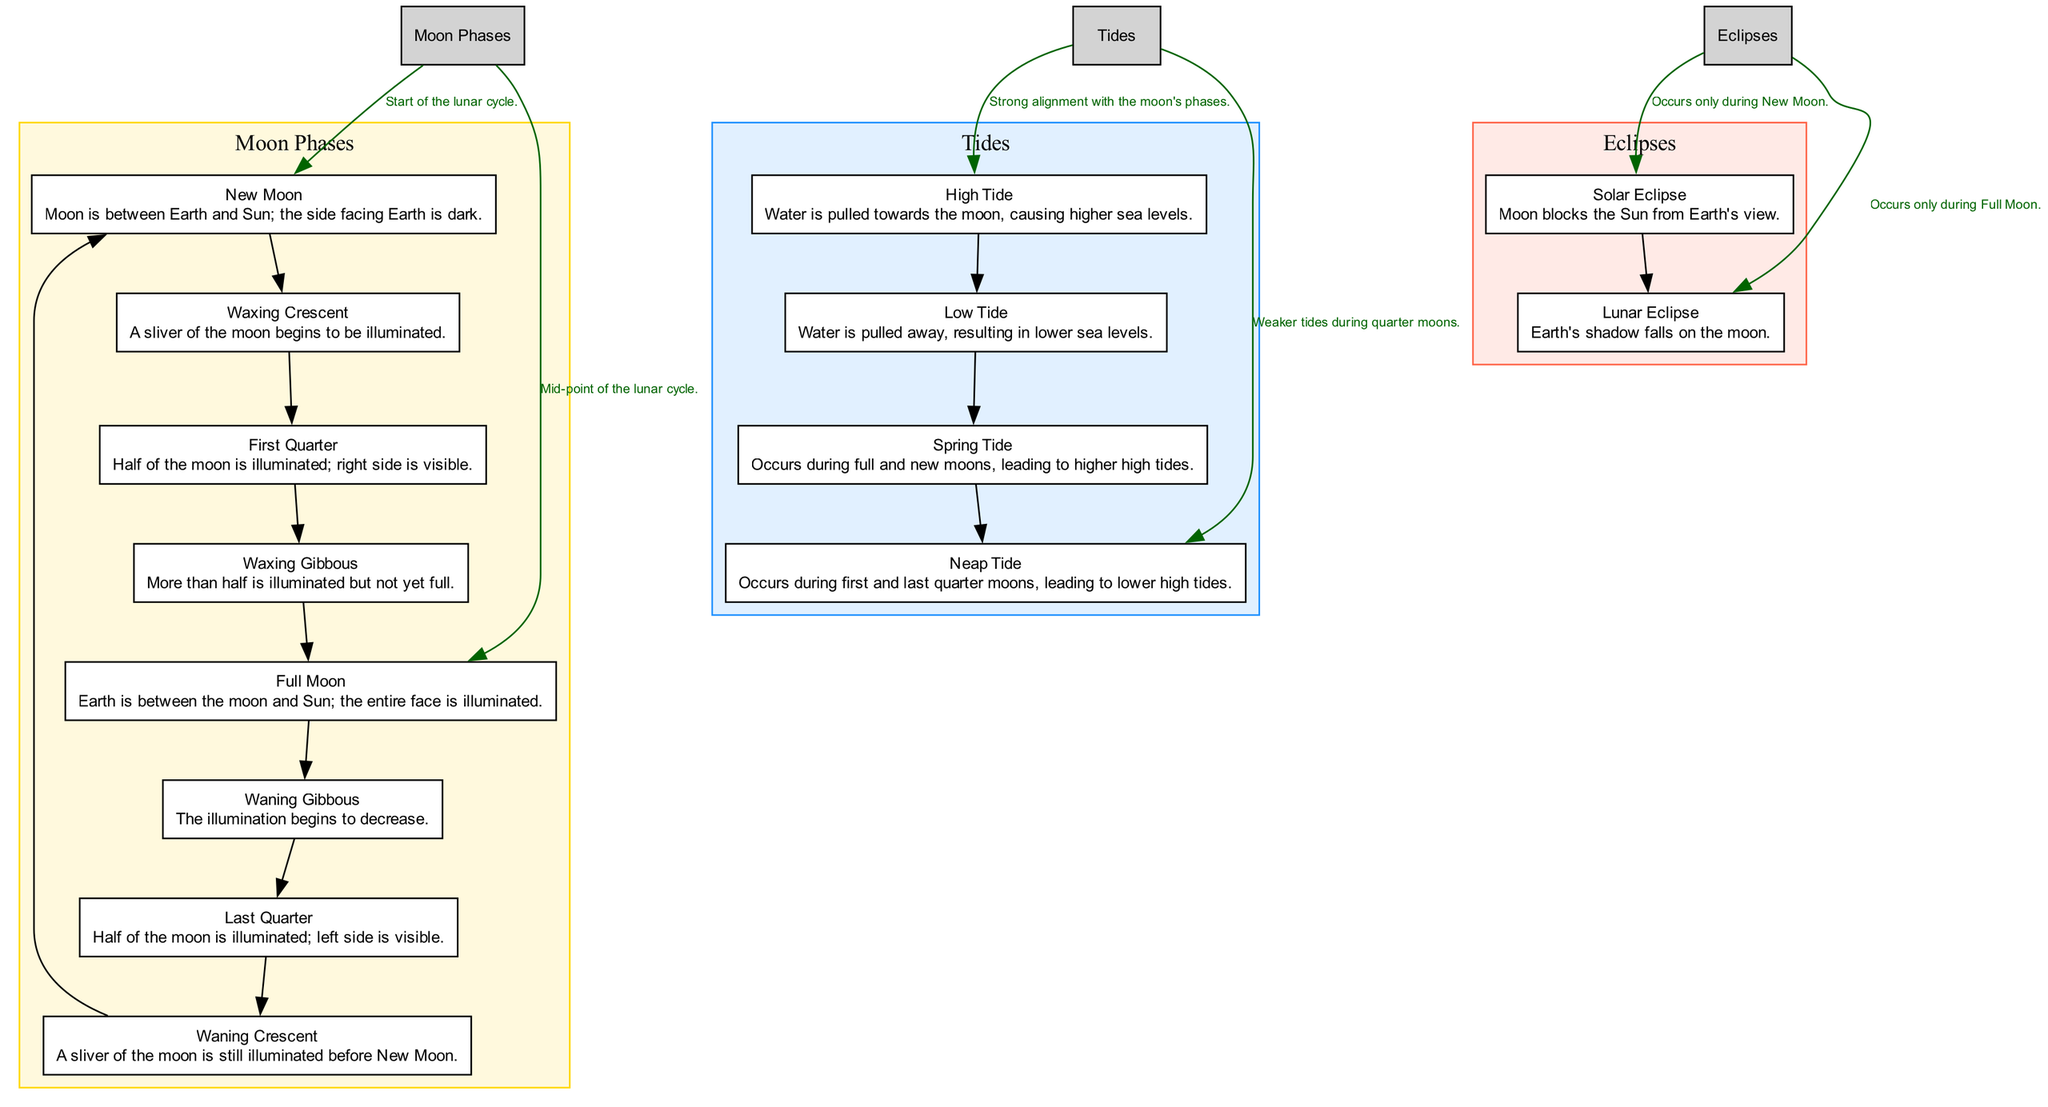What is the first phase of the moon? The diagram clearly indicates that the first phase in the Moon Phases section is labeled "New Moon."
Answer: New Moon How many phases of the moon are shown in the diagram? Counting the nodes under the Moon Phases section, there are eight distinct phases listed, from New Moon to Waning Crescent.
Answer: Eight What phase of the moon is directly before the Full Moon? The diagram reflects that the phase prior to the Full Moon is the Waxing Gibbous in the Moon Phases section.
Answer: Waxing Gibbous During which moon phase does a Solar Eclipse occur? The annotations state that a Solar Eclipse uniquely occurs during the New Moon phase, linking it to the corresponding node.
Answer: New Moon What type of tide occurs during the Full Moon? The diagram illustrates that High Tide is a significant occurrence during a Full Moon, as indicated in the Tides section.
Answer: High Tide What is the relationship between the Last Quarter and Neap Tide? The diagram shows that Neap Tide occurs during the Last Quarter, demonstrating a connection between these two elements in the annotations.
Answer: Neap Tide Which tidal phenomenon leads to higher high tides? The annotation specifies that Spring Tide leads to higher high tides and occurs during both full and new moons, linking this phenomenon to those phases.
Answer: Spring Tide How many types of eclipses are described in the diagram? The Eclipses section lists two types of eclipses: Solar Eclipse and Lunar Eclipse, confirming the total count.
Answer: Two Which tidal situation results from the moon's gravitational pull when it is located in its high phase? The diagram explains that High Tide results from the gravitational pull of the moon when it is prominently positioned, affecting sea levels.
Answer: High Tide 